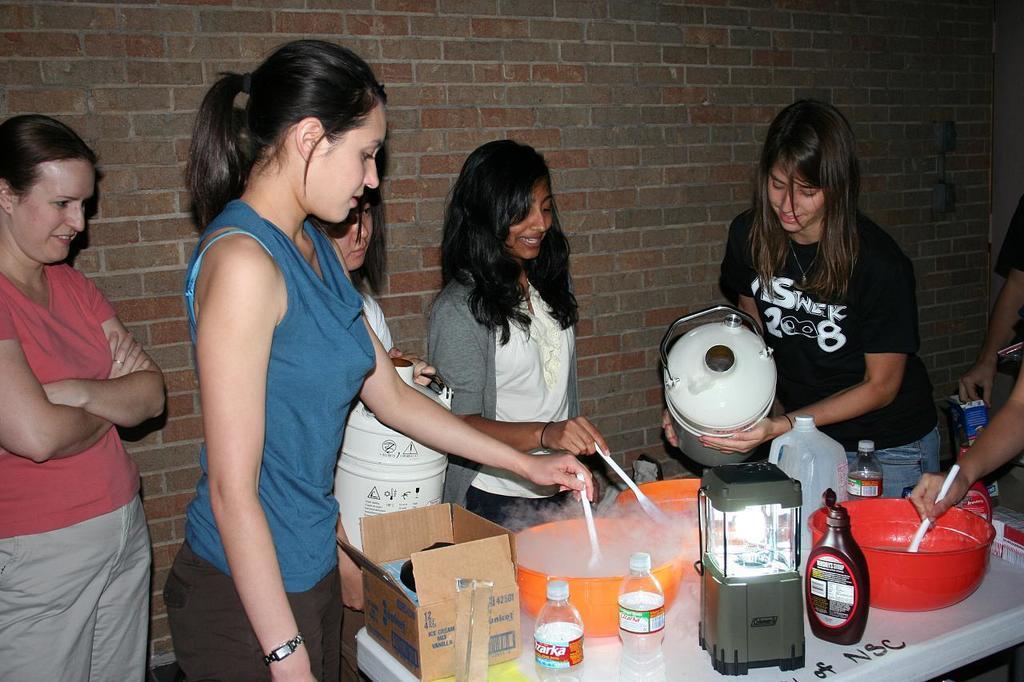In one or two sentences, can you explain what this image depicts? In this image I can see number of women are standing and in the centre I can see two of them are holding white colour things and I can also see few of them are holding plastic things. In the front of them I can see a table and on it I can see few bottles, a light, few containers and a box. 